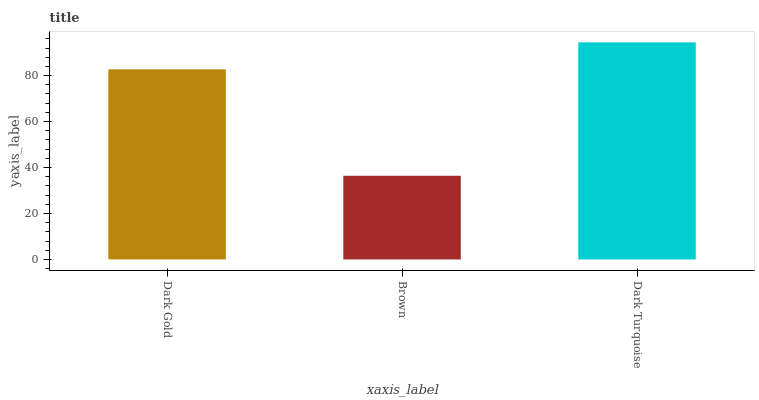Is Brown the minimum?
Answer yes or no. Yes. Is Dark Turquoise the maximum?
Answer yes or no. Yes. Is Dark Turquoise the minimum?
Answer yes or no. No. Is Brown the maximum?
Answer yes or no. No. Is Dark Turquoise greater than Brown?
Answer yes or no. Yes. Is Brown less than Dark Turquoise?
Answer yes or no. Yes. Is Brown greater than Dark Turquoise?
Answer yes or no. No. Is Dark Turquoise less than Brown?
Answer yes or no. No. Is Dark Gold the high median?
Answer yes or no. Yes. Is Dark Gold the low median?
Answer yes or no. Yes. Is Brown the high median?
Answer yes or no. No. Is Dark Turquoise the low median?
Answer yes or no. No. 